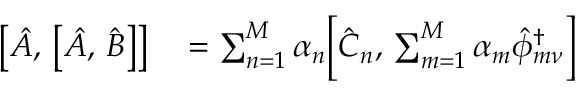<formula> <loc_0><loc_0><loc_500><loc_500>\begin{array} { r l } { \left [ \hat { A } , \, \left [ \hat { A } , \, \hat { B } \right ] \right ] } & = \sum _ { n = 1 } ^ { M } \alpha _ { n } \left [ \hat { C } _ { n } , \, \sum _ { m = 1 } ^ { M } \alpha _ { m } \hat { \phi } _ { m \nu } ^ { \dagger } \right ] } \end{array}</formula> 